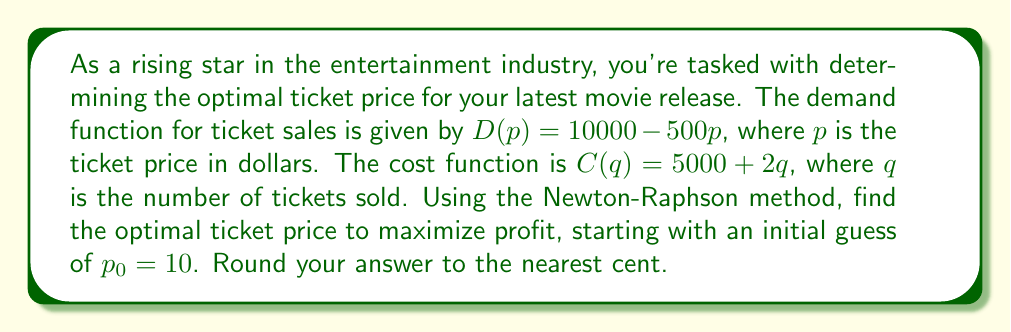Can you solve this math problem? Let's approach this step-by-step:

1) The profit function is given by:
   $\Pi(p) = pD(p) - C(D(p))$
   $\Pi(p) = p(10000 - 500p) - (5000 + 2(10000 - 500p))$
   $\Pi(p) = 10000p - 500p^2 - 5000 - 20000 + 1000p$
   $\Pi(p) = -500p^2 + 11000p - 25000$

2) To maximize profit, we need to find where $\frac{d\Pi}{dp} = 0$:
   $\frac{d\Pi}{dp} = -1000p + 11000$

3) The Newton-Raphson method is given by:
   $p_{n+1} = p_n - \frac{f(p_n)}{f'(p_n)}$

   Where $f(p) = \frac{d\Pi}{dp} = -1000p + 11000$
   and $f'(p) = -1000$

4) Let's iterate:
   $p_1 = 10 - \frac{-1000(10) + 11000}{-1000} = 11$
   
   $p_2 = 11 - \frac{-1000(11) + 11000}{-1000} = 11$

5) The method converges immediately to $p = 11$.

6) To verify, we can check the second derivative:
   $\frac{d^2\Pi}{dp^2} = -1000 < 0$, confirming this is a maximum.
Answer: $11.00 